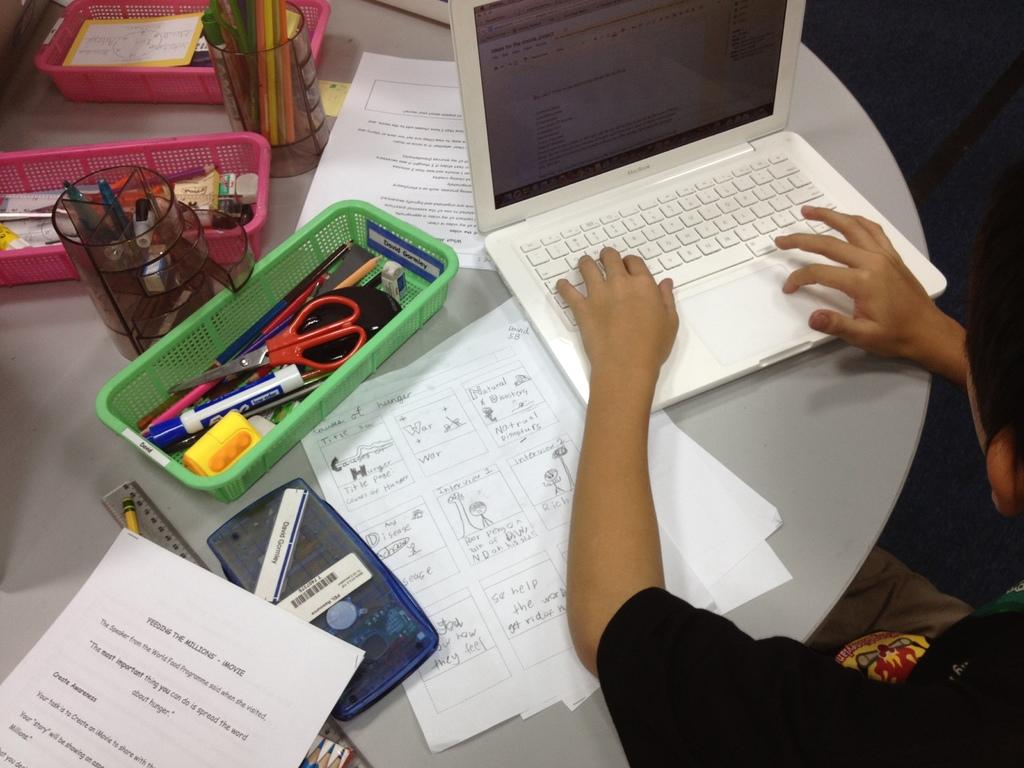<image>
Share a concise interpretation of the image provided. A person is working on a laptop with notes about feeding the millions on the left. 